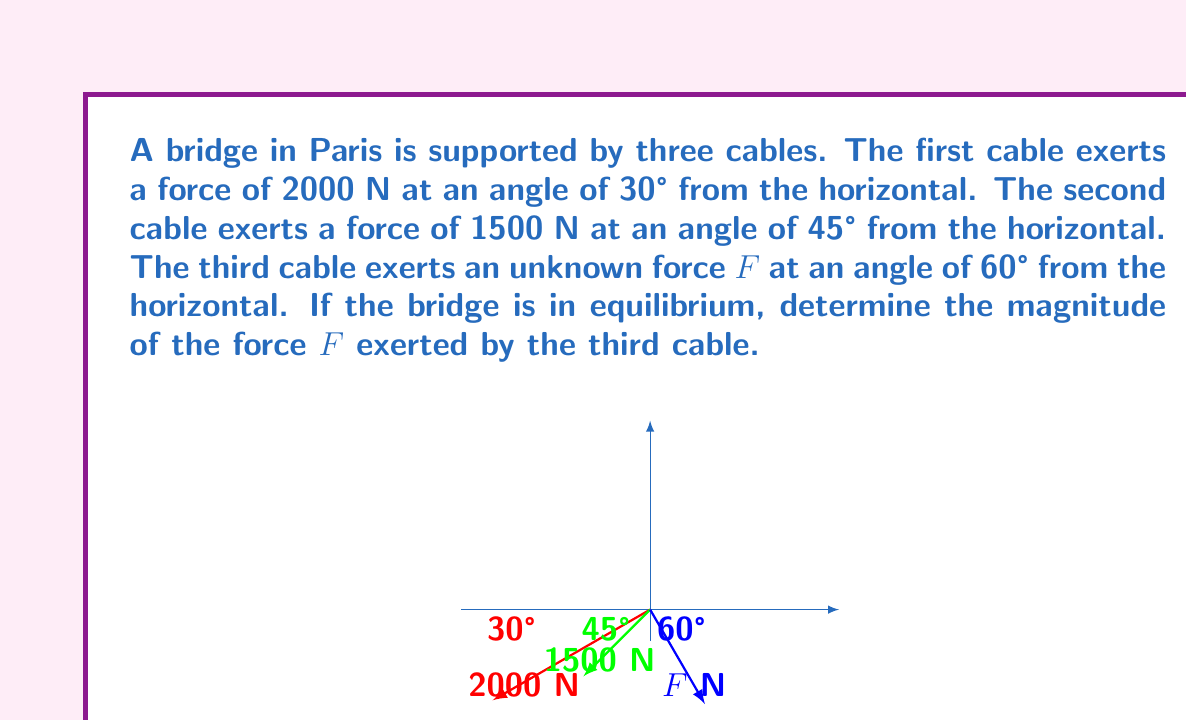Provide a solution to this math problem. Let's solve this problem step by step:

1) First, we need to break down each force into its horizontal and vertical components:

   For the first cable:
   $F_{1x} = 2000 \cos 30° = 2000 \cdot \frac{\sqrt{3}}{2} = 1000\sqrt{3}$ N
   $F_{1y} = 2000 \sin 30° = 2000 \cdot \frac{1}{2} = 1000$ N

   For the second cable:
   $F_{2x} = 1500 \cos 45° = 1500 \cdot \frac{\sqrt{2}}{2} = 750\sqrt{2}$ N
   $F_{2y} = 1500 \sin 45° = 1500 \cdot \frac{\sqrt{2}}{2} = 750\sqrt{2}$ N

   For the third cable:
   $F_{3x} = F \cos 60° = F \cdot \frac{1}{2} = \frac{F}{2}$ N
   $F_{3y} = F \sin 60° = F \cdot \frac{\sqrt{3}}{2} = \frac{F\sqrt{3}}{2}$ N

2) For the bridge to be in equilibrium, the sum of forces in both x and y directions must be zero:

   $$\sum F_x = 0: -1000\sqrt{3} - 750\sqrt{2} + \frac{F}{2} = 0$$
   $$\sum F_y = 0: 1000 + 750\sqrt{2} + \frac{F\sqrt{3}}{2} = 0$$

3) From the second equation:
   $$\frac{F\sqrt{3}}{2} = -1000 - 750\sqrt{2}$$
   $$F = \frac{-2000 - 1500\sqrt{2}}{\sqrt{3}}$$

4) Simplify:
   $$F = \frac{-2000\sqrt{3} - 1500\sqrt{6}}{3}$$

5) Rationalize the denominator:
   $$F = \frac{-2000\sqrt{3} - 1500\sqrt{6}}{3} \cdot \frac{\sqrt{3}}{\sqrt{3}}$$
   $$F = \frac{-2000 \cdot 3 - 1500\sqrt{2} \cdot 3}{3\sqrt{3}}$$
   $$F = \frac{-6000 - 4500\sqrt{2}}{\sqrt{3}}$$

6) Simplify further:
   $$F = -2000\sqrt{3} - 1500\sqrt{6}$$

7) Calculate the numerical value:
   $$F \approx 3464.1 + 3674.2 = 7138.3$$ N

Therefore, the magnitude of the force $F$ exerted by the third cable is approximately 7138.3 N.
Answer: $F = -2000\sqrt{3} - 1500\sqrt{6} \approx 7138.3$ N 